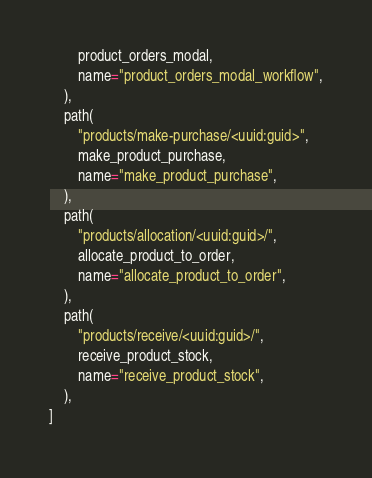Convert code to text. <code><loc_0><loc_0><loc_500><loc_500><_Python_>        product_orders_modal,
        name="product_orders_modal_workflow",
    ),
    path(
        "products/make-purchase/<uuid:guid>",
        make_product_purchase,
        name="make_product_purchase",
    ),
    path(
        "products/allocation/<uuid:guid>/",
        allocate_product_to_order,
        name="allocate_product_to_order",
    ),
    path(
        "products/receive/<uuid:guid>/",
        receive_product_stock,
        name="receive_product_stock",
    ),
]
</code> 